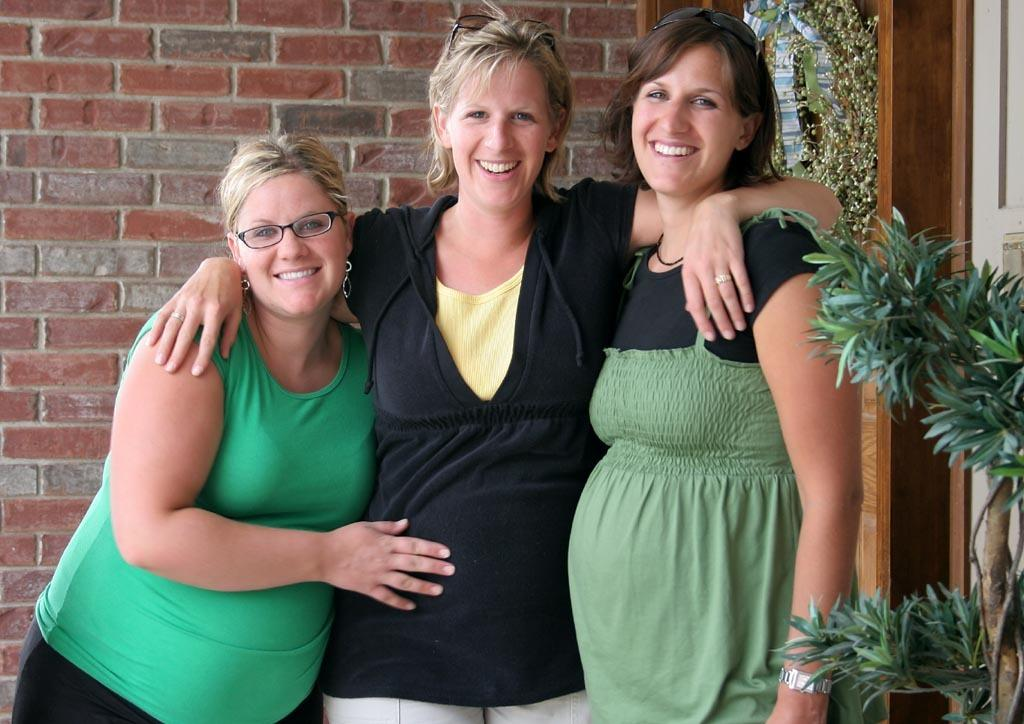How many people are in the image? There are three women in the image. What are the women doing in the image? The women are standing together and laughing. What can be seen in the background of the image? There is a wall and plants in the background of the image. What type of shoes are the women wearing on their toes in the image? There is no mention of shoes or toes in the image, so we cannot determine what type of shoes the women might be wearing. 